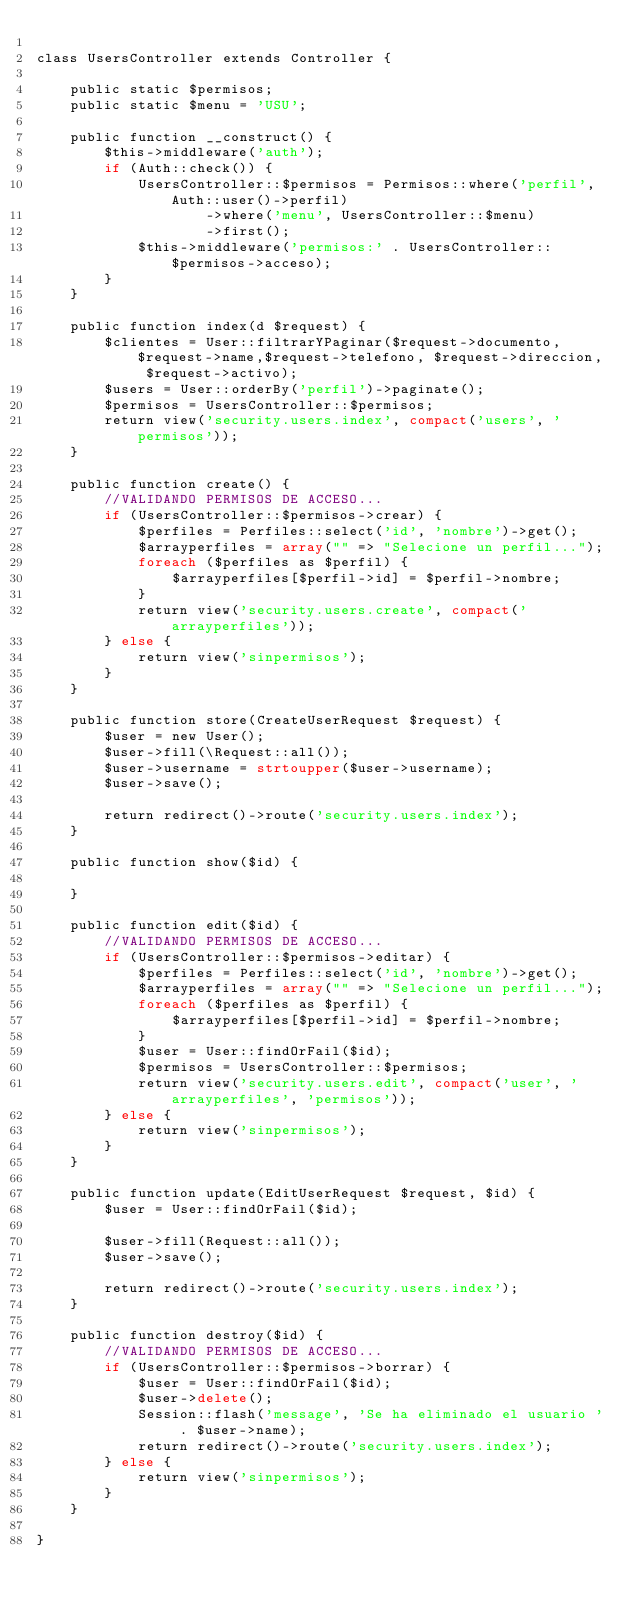Convert code to text. <code><loc_0><loc_0><loc_500><loc_500><_PHP_>
class UsersController extends Controller {

    public static $permisos;
    public static $menu = 'USU';

    public function __construct() {
        $this->middleware('auth');
        if (Auth::check()) {
            UsersController::$permisos = Permisos::where('perfil', Auth::user()->perfil)
                    ->where('menu', UsersController::$menu)
                    ->first();
            $this->middleware('permisos:' . UsersController::$permisos->acceso);
        }
    }

    public function index(d $request) {
        $clientes = User::filtrarYPaginar($request->documento,$request->name,$request->telefono, $request->direccion, $request->activo);
        $users = User::orderBy('perfil')->paginate();
        $permisos = UsersController::$permisos;
        return view('security.users.index', compact('users', 'permisos'));
    }

    public function create() {
        //VALIDANDO PERMISOS DE ACCESO...
        if (UsersController::$permisos->crear) {
            $perfiles = Perfiles::select('id', 'nombre')->get();
            $arrayperfiles = array("" => "Selecione un perfil...");
            foreach ($perfiles as $perfil) {
                $arrayperfiles[$perfil->id] = $perfil->nombre;
            }
            return view('security.users.create', compact('arrayperfiles'));
        } else {
            return view('sinpermisos');
        }
    }

    public function store(CreateUserRequest $request) {
        $user = new User();
        $user->fill(\Request::all());
        $user->username = strtoupper($user->username);
        $user->save();

        return redirect()->route('security.users.index');
    }

    public function show($id) {
        
    }

    public function edit($id) {
        //VALIDANDO PERMISOS DE ACCESO...
        if (UsersController::$permisos->editar) {
            $perfiles = Perfiles::select('id', 'nombre')->get();
            $arrayperfiles = array("" => "Selecione un perfil...");
            foreach ($perfiles as $perfil) {
                $arrayperfiles[$perfil->id] = $perfil->nombre;
            }
            $user = User::findOrFail($id);
            $permisos = UsersController::$permisos;
            return view('security.users.edit', compact('user', 'arrayperfiles', 'permisos'));
        } else {
            return view('sinpermisos');
        }
    }

    public function update(EditUserRequest $request, $id) {
        $user = User::findOrFail($id);

        $user->fill(Request::all());
        $user->save();

        return redirect()->route('security.users.index');
    }

    public function destroy($id) {
        //VALIDANDO PERMISOS DE ACCESO...
        if (UsersController::$permisos->borrar) {
            $user = User::findOrFail($id);
            $user->delete();
            Session::flash('message', 'Se ha eliminado el usuario ' . $user->name);
            return redirect()->route('security.users.index');
        } else {
            return view('sinpermisos');
        }
    }

}
</code> 